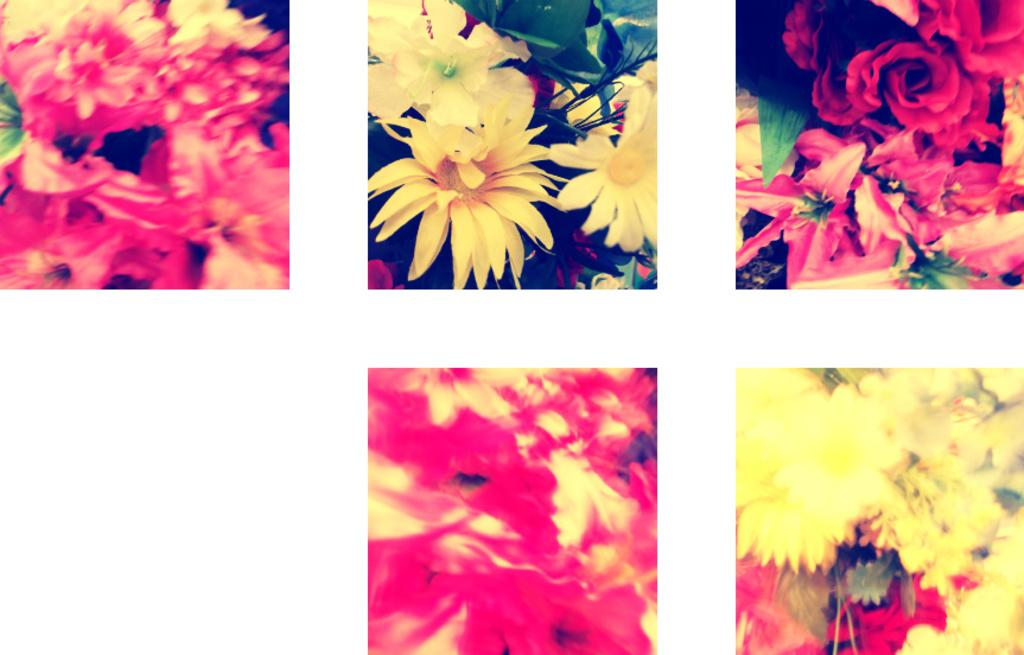What type of images are present in the collage? The collage contains photos of flowers and leaves. What colors can be seen in the flowers of the collage? The flowers in the collage have pink, red, and yellow colors. What type of neck can be seen in the image? There is no neck present in the image; it contains a collage of flowers and leaves. What condition is the stretch in the image? There is no stretch present in the image; it contains a collage of flowers and leaves. 